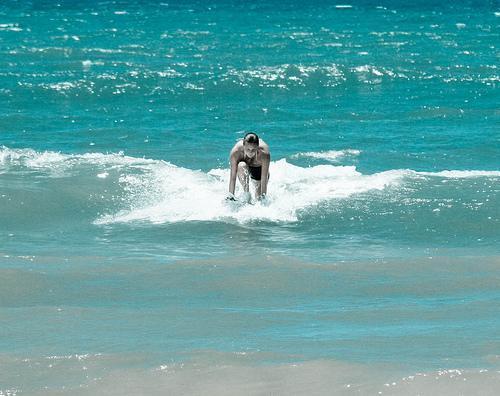How many hands are holding the surfboard?
Give a very brief answer. 2. How many people are in this photo?
Give a very brief answer. 1. 